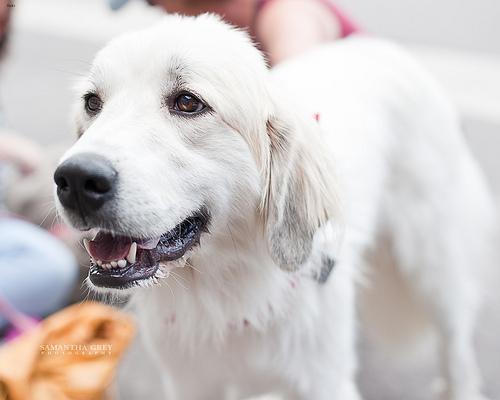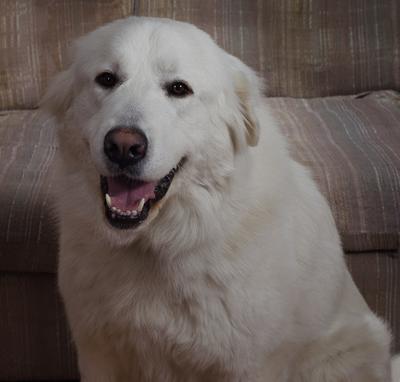The first image is the image on the left, the second image is the image on the right. For the images displayed, is the sentence "There is a picture of the white dogs full body and not just his head." factually correct? Answer yes or no. No. The first image is the image on the left, the second image is the image on the right. For the images shown, is this caption "One of the dogs is sitting in front of the sofa." true? Answer yes or no. Yes. 